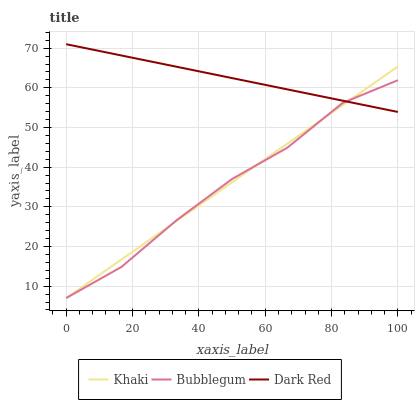Does Khaki have the minimum area under the curve?
Answer yes or no. No. Does Khaki have the maximum area under the curve?
Answer yes or no. No. Is Bubblegum the smoothest?
Answer yes or no. No. Is Khaki the roughest?
Answer yes or no. No. Does Khaki have the highest value?
Answer yes or no. No. 